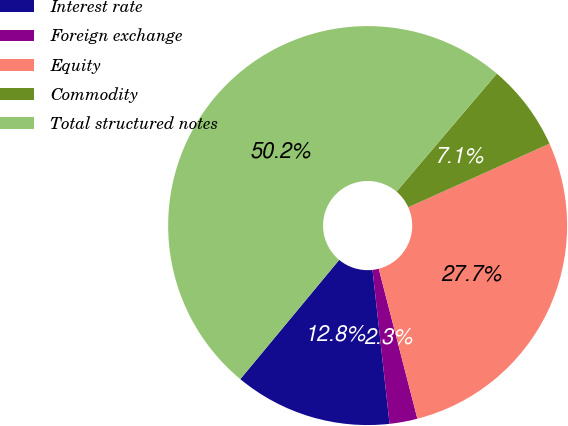Convert chart. <chart><loc_0><loc_0><loc_500><loc_500><pie_chart><fcel>Interest rate<fcel>Foreign exchange<fcel>Equity<fcel>Commodity<fcel>Total structured notes<nl><fcel>12.77%<fcel>2.26%<fcel>27.72%<fcel>7.05%<fcel>50.2%<nl></chart> 